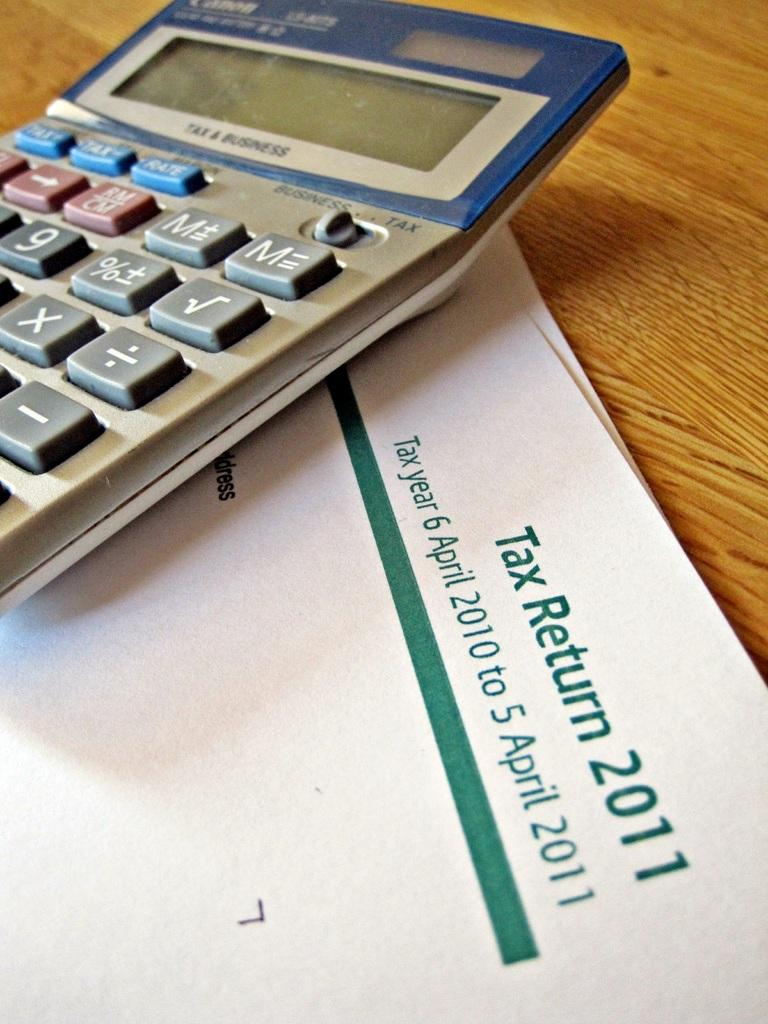Provide a one-sentence caption for the provided image. A calculator sits on top of a tax return from 2011. 